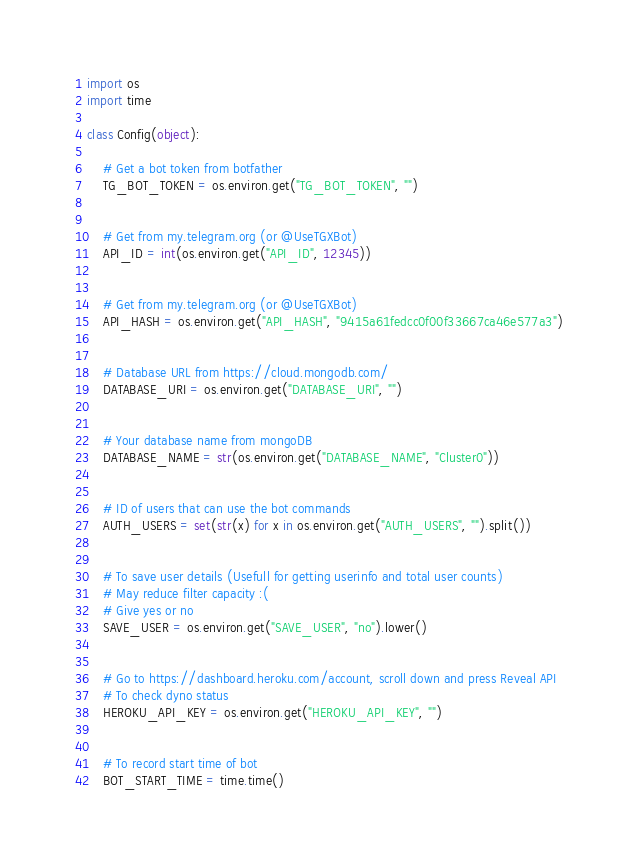Convert code to text. <code><loc_0><loc_0><loc_500><loc_500><_Python_>import os
import time

class Config(object):

    # Get a bot token from botfather
    TG_BOT_TOKEN = os.environ.get("TG_BOT_TOKEN", "")


    # Get from my.telegram.org (or @UseTGXBot)
    API_ID = int(os.environ.get("API_ID", 12345))


    # Get from my.telegram.org (or @UseTGXBot)
    API_HASH = os.environ.get("API_HASH", "9415a61fedcc0f00f33667ca46e577a3")
    
    
    # Database URL from https://cloud.mongodb.com/
    DATABASE_URI = os.environ.get("DATABASE_URI", "")


    # Your database name from mongoDB
    DATABASE_NAME = str(os.environ.get("DATABASE_NAME", "Cluster0"))


    # ID of users that can use the bot commands
    AUTH_USERS = set(str(x) for x in os.environ.get("AUTH_USERS", "").split())


    # To save user details (Usefull for getting userinfo and total user counts)
    # May reduce filter capacity :(
    # Give yes or no
    SAVE_USER = os.environ.get("SAVE_USER", "no").lower()


    # Go to https://dashboard.heroku.com/account, scroll down and press Reveal API
    # To check dyno status
    HEROKU_API_KEY = os.environ.get("HEROKU_API_KEY", "")


    # To record start time of bot
    BOT_START_TIME = time.time()
</code> 